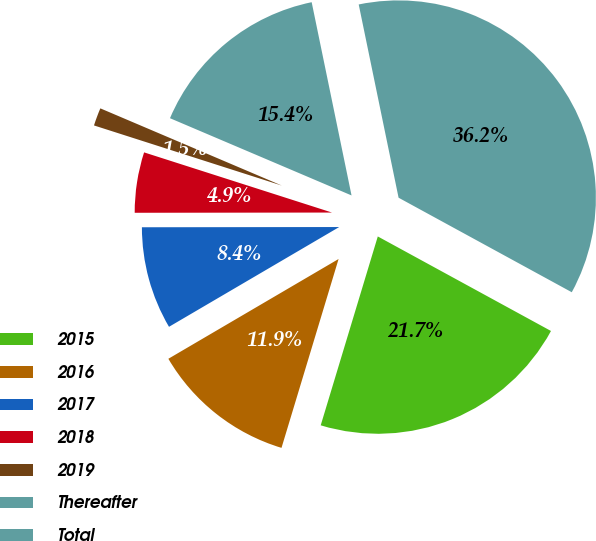Convert chart. <chart><loc_0><loc_0><loc_500><loc_500><pie_chart><fcel>2015<fcel>2016<fcel>2017<fcel>2018<fcel>2019<fcel>Thereafter<fcel>Total<nl><fcel>21.72%<fcel>11.89%<fcel>8.42%<fcel>4.95%<fcel>1.47%<fcel>15.36%<fcel>36.19%<nl></chart> 